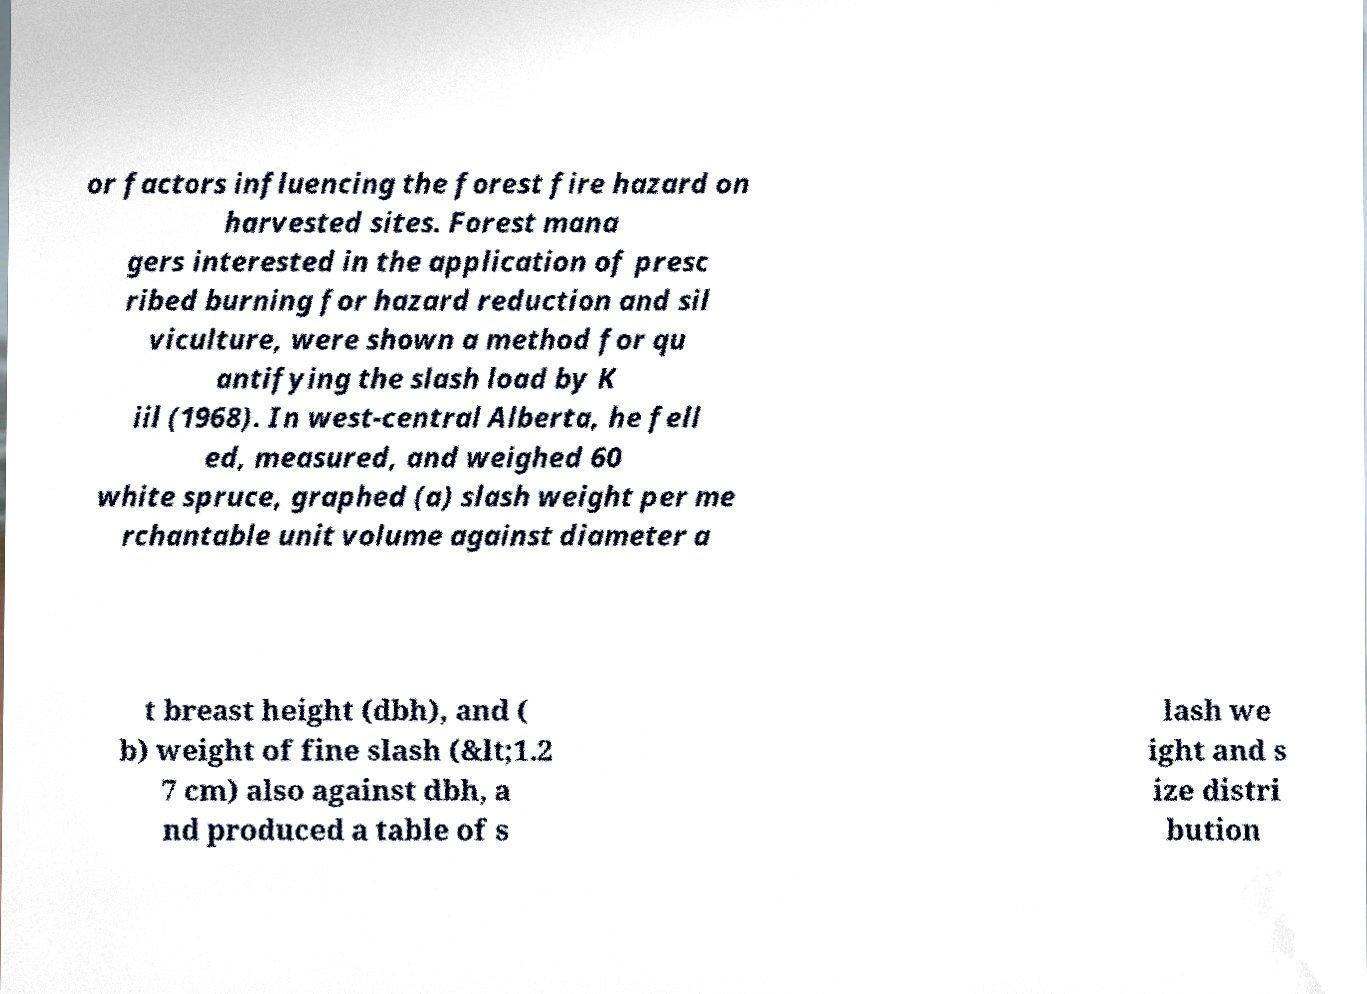Can you accurately transcribe the text from the provided image for me? or factors influencing the forest fire hazard on harvested sites. Forest mana gers interested in the application of presc ribed burning for hazard reduction and sil viculture, were shown a method for qu antifying the slash load by K iil (1968). In west-central Alberta, he fell ed, measured, and weighed 60 white spruce, graphed (a) slash weight per me rchantable unit volume against diameter a t breast height (dbh), and ( b) weight of fine slash (&lt;1.2 7 cm) also against dbh, a nd produced a table of s lash we ight and s ize distri bution 